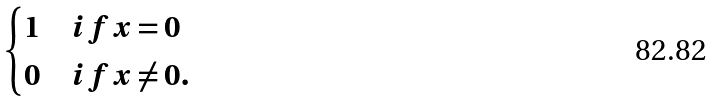Convert formula to latex. <formula><loc_0><loc_0><loc_500><loc_500>\begin{cases} 1 & i f \, x = 0 \\ 0 & i f \, x \neq 0 . \end{cases}</formula> 